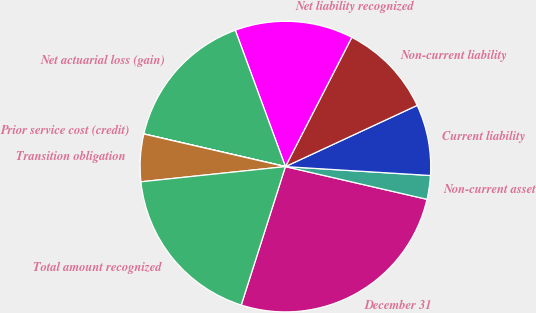<chart> <loc_0><loc_0><loc_500><loc_500><pie_chart><fcel>December 31<fcel>Non-current asset<fcel>Current liability<fcel>Non-current liability<fcel>Net liability recognized<fcel>Net actuarial loss (gain)<fcel>Prior service cost (credit)<fcel>Transition obligation<fcel>Total amount recognized<nl><fcel>26.31%<fcel>2.64%<fcel>7.9%<fcel>10.53%<fcel>13.16%<fcel>15.79%<fcel>0.01%<fcel>5.27%<fcel>18.42%<nl></chart> 